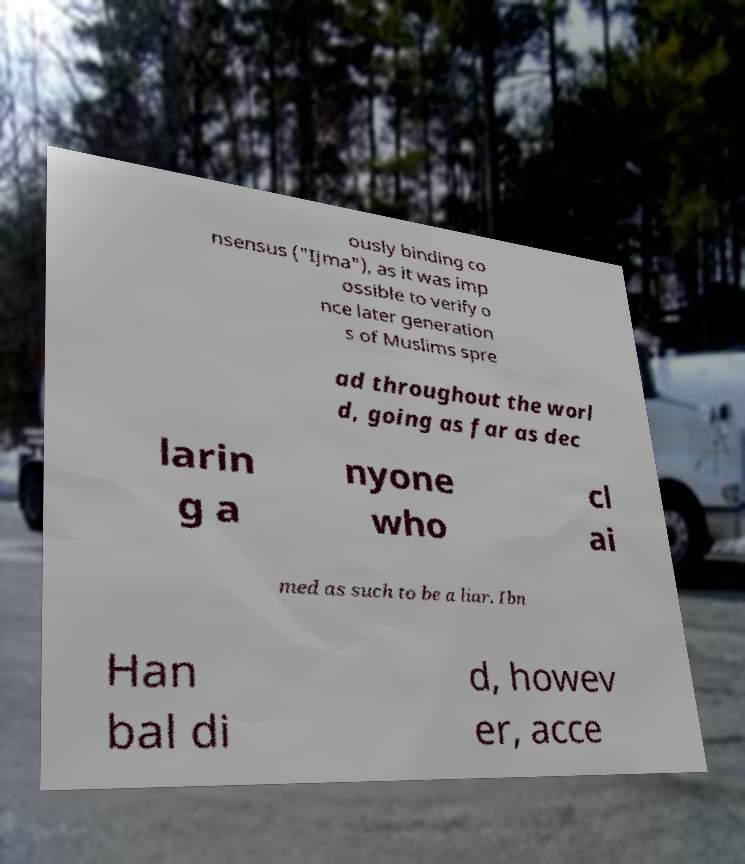Could you assist in decoding the text presented in this image and type it out clearly? ously binding co nsensus ("Ijma"), as it was imp ossible to verify o nce later generation s of Muslims spre ad throughout the worl d, going as far as dec larin g a nyone who cl ai med as such to be a liar. Ibn Han bal di d, howev er, acce 